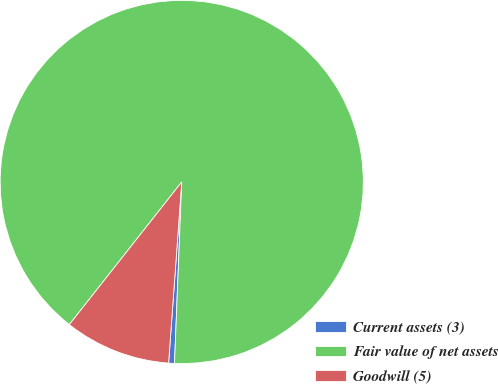Convert chart. <chart><loc_0><loc_0><loc_500><loc_500><pie_chart><fcel>Current assets (3)<fcel>Fair value of net assets<fcel>Goodwill (5)<nl><fcel>0.52%<fcel>90.01%<fcel>9.47%<nl></chart> 